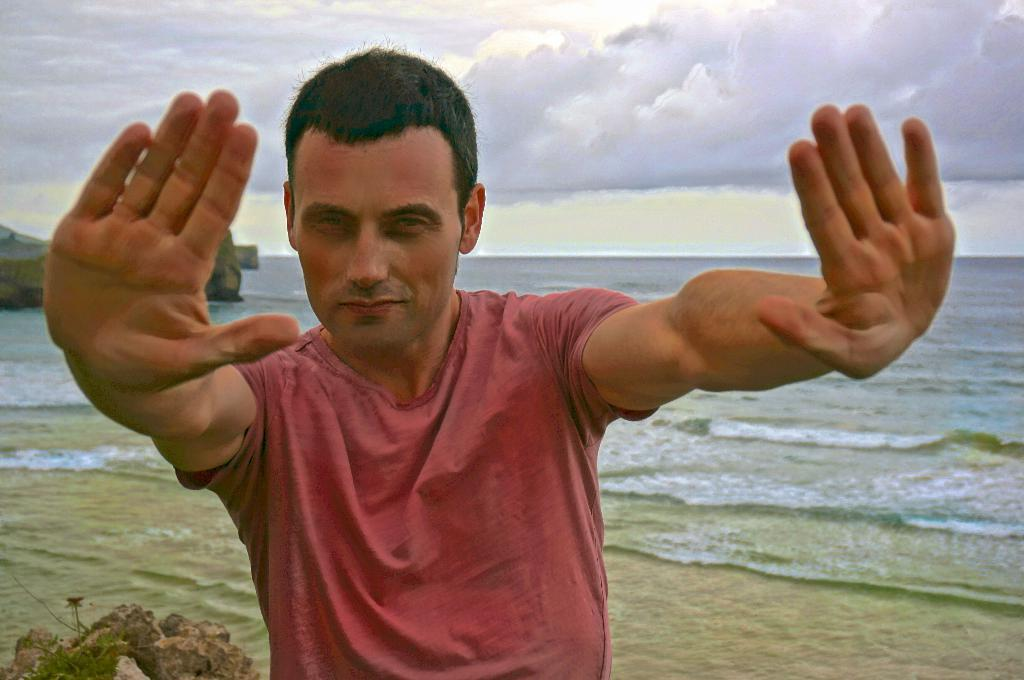Who is present in the image? There is a man in the image. What is the man wearing? The man is wearing clothes. What natural elements can be seen in the image? There is a rock, sand, water, and a cloudy sky in the image. What type of knife is being used to cut the head in the image? There is no head or knife present in the image. 